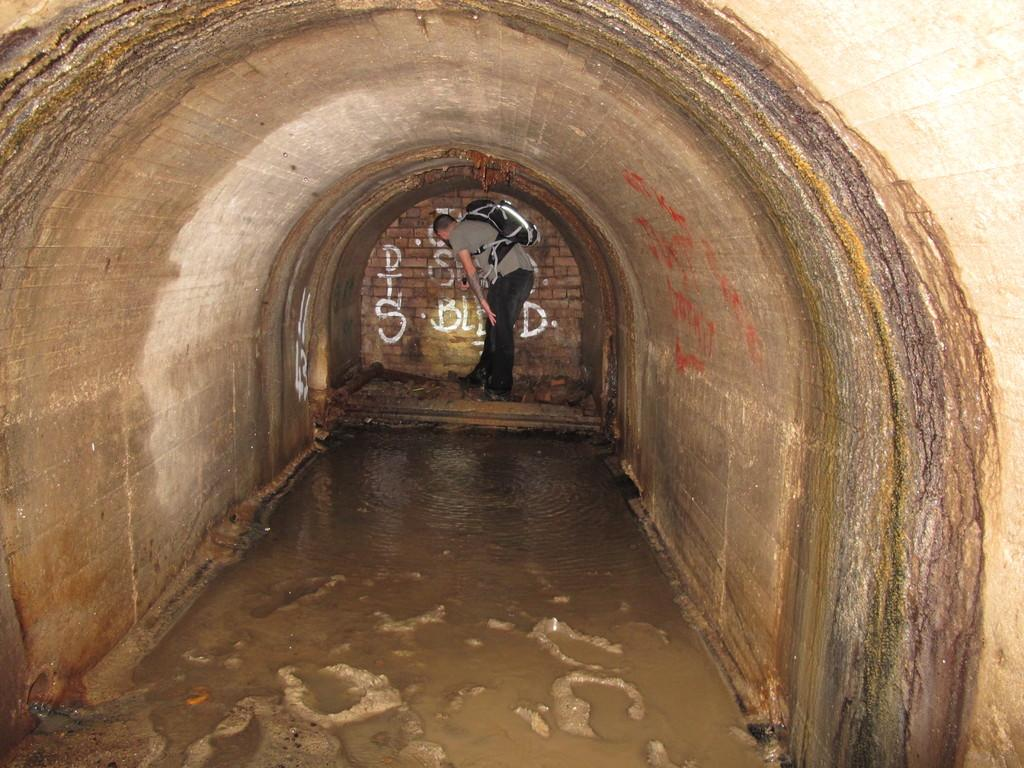What is the main feature of the image? There is a tunnel in the image. What can be seen on the ground in the image? There is water on the ground in the image. What is visible in the background of the image? There is a brick wall in the background of the image. What is written on the brick wall? Something is written on the brick wall. Who is present in the image? There is a person in the image. What is the person holding? The person is holding a bag. How many apples are on the seat in the image? There is no mention of apples or a seat in the image. 